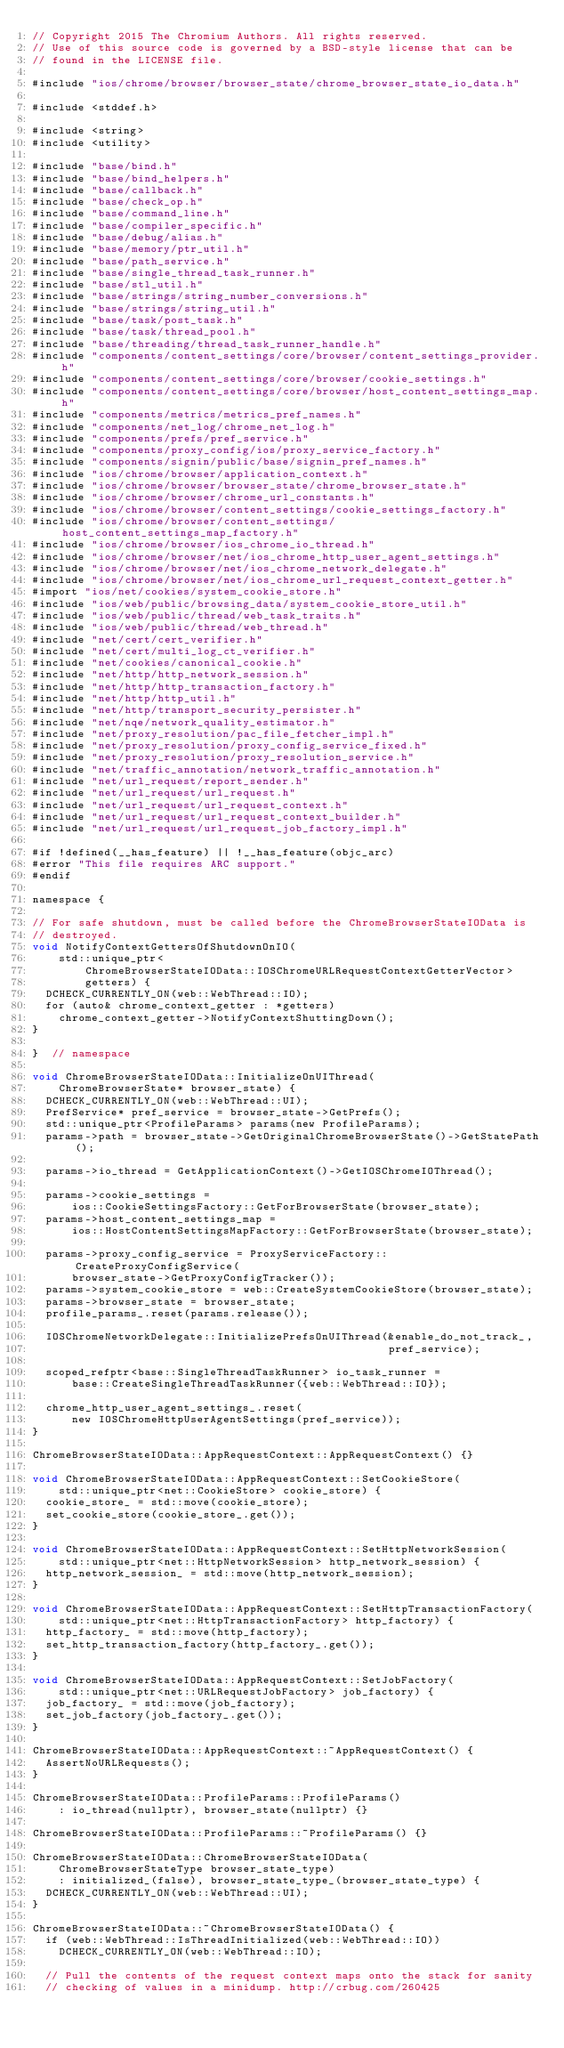<code> <loc_0><loc_0><loc_500><loc_500><_ObjectiveC_>// Copyright 2015 The Chromium Authors. All rights reserved.
// Use of this source code is governed by a BSD-style license that can be
// found in the LICENSE file.

#include "ios/chrome/browser/browser_state/chrome_browser_state_io_data.h"

#include <stddef.h>

#include <string>
#include <utility>

#include "base/bind.h"
#include "base/bind_helpers.h"
#include "base/callback.h"
#include "base/check_op.h"
#include "base/command_line.h"
#include "base/compiler_specific.h"
#include "base/debug/alias.h"
#include "base/memory/ptr_util.h"
#include "base/path_service.h"
#include "base/single_thread_task_runner.h"
#include "base/stl_util.h"
#include "base/strings/string_number_conversions.h"
#include "base/strings/string_util.h"
#include "base/task/post_task.h"
#include "base/task/thread_pool.h"
#include "base/threading/thread_task_runner_handle.h"
#include "components/content_settings/core/browser/content_settings_provider.h"
#include "components/content_settings/core/browser/cookie_settings.h"
#include "components/content_settings/core/browser/host_content_settings_map.h"
#include "components/metrics/metrics_pref_names.h"
#include "components/net_log/chrome_net_log.h"
#include "components/prefs/pref_service.h"
#include "components/proxy_config/ios/proxy_service_factory.h"
#include "components/signin/public/base/signin_pref_names.h"
#include "ios/chrome/browser/application_context.h"
#include "ios/chrome/browser/browser_state/chrome_browser_state.h"
#include "ios/chrome/browser/chrome_url_constants.h"
#include "ios/chrome/browser/content_settings/cookie_settings_factory.h"
#include "ios/chrome/browser/content_settings/host_content_settings_map_factory.h"
#include "ios/chrome/browser/ios_chrome_io_thread.h"
#include "ios/chrome/browser/net/ios_chrome_http_user_agent_settings.h"
#include "ios/chrome/browser/net/ios_chrome_network_delegate.h"
#include "ios/chrome/browser/net/ios_chrome_url_request_context_getter.h"
#import "ios/net/cookies/system_cookie_store.h"
#include "ios/web/public/browsing_data/system_cookie_store_util.h"
#include "ios/web/public/thread/web_task_traits.h"
#include "ios/web/public/thread/web_thread.h"
#include "net/cert/cert_verifier.h"
#include "net/cert/multi_log_ct_verifier.h"
#include "net/cookies/canonical_cookie.h"
#include "net/http/http_network_session.h"
#include "net/http/http_transaction_factory.h"
#include "net/http/http_util.h"
#include "net/http/transport_security_persister.h"
#include "net/nqe/network_quality_estimator.h"
#include "net/proxy_resolution/pac_file_fetcher_impl.h"
#include "net/proxy_resolution/proxy_config_service_fixed.h"
#include "net/proxy_resolution/proxy_resolution_service.h"
#include "net/traffic_annotation/network_traffic_annotation.h"
#include "net/url_request/report_sender.h"
#include "net/url_request/url_request.h"
#include "net/url_request/url_request_context.h"
#include "net/url_request/url_request_context_builder.h"
#include "net/url_request/url_request_job_factory_impl.h"

#if !defined(__has_feature) || !__has_feature(objc_arc)
#error "This file requires ARC support."
#endif

namespace {

// For safe shutdown, must be called before the ChromeBrowserStateIOData is
// destroyed.
void NotifyContextGettersOfShutdownOnIO(
    std::unique_ptr<
        ChromeBrowserStateIOData::IOSChromeURLRequestContextGetterVector>
        getters) {
  DCHECK_CURRENTLY_ON(web::WebThread::IO);
  for (auto& chrome_context_getter : *getters)
    chrome_context_getter->NotifyContextShuttingDown();
}

}  // namespace

void ChromeBrowserStateIOData::InitializeOnUIThread(
    ChromeBrowserState* browser_state) {
  DCHECK_CURRENTLY_ON(web::WebThread::UI);
  PrefService* pref_service = browser_state->GetPrefs();
  std::unique_ptr<ProfileParams> params(new ProfileParams);
  params->path = browser_state->GetOriginalChromeBrowserState()->GetStatePath();

  params->io_thread = GetApplicationContext()->GetIOSChromeIOThread();

  params->cookie_settings =
      ios::CookieSettingsFactory::GetForBrowserState(browser_state);
  params->host_content_settings_map =
      ios::HostContentSettingsMapFactory::GetForBrowserState(browser_state);

  params->proxy_config_service = ProxyServiceFactory::CreateProxyConfigService(
      browser_state->GetProxyConfigTracker());
  params->system_cookie_store = web::CreateSystemCookieStore(browser_state);
  params->browser_state = browser_state;
  profile_params_.reset(params.release());

  IOSChromeNetworkDelegate::InitializePrefsOnUIThread(&enable_do_not_track_,
                                                      pref_service);

  scoped_refptr<base::SingleThreadTaskRunner> io_task_runner =
      base::CreateSingleThreadTaskRunner({web::WebThread::IO});

  chrome_http_user_agent_settings_.reset(
      new IOSChromeHttpUserAgentSettings(pref_service));
}

ChromeBrowserStateIOData::AppRequestContext::AppRequestContext() {}

void ChromeBrowserStateIOData::AppRequestContext::SetCookieStore(
    std::unique_ptr<net::CookieStore> cookie_store) {
  cookie_store_ = std::move(cookie_store);
  set_cookie_store(cookie_store_.get());
}

void ChromeBrowserStateIOData::AppRequestContext::SetHttpNetworkSession(
    std::unique_ptr<net::HttpNetworkSession> http_network_session) {
  http_network_session_ = std::move(http_network_session);
}

void ChromeBrowserStateIOData::AppRequestContext::SetHttpTransactionFactory(
    std::unique_ptr<net::HttpTransactionFactory> http_factory) {
  http_factory_ = std::move(http_factory);
  set_http_transaction_factory(http_factory_.get());
}

void ChromeBrowserStateIOData::AppRequestContext::SetJobFactory(
    std::unique_ptr<net::URLRequestJobFactory> job_factory) {
  job_factory_ = std::move(job_factory);
  set_job_factory(job_factory_.get());
}

ChromeBrowserStateIOData::AppRequestContext::~AppRequestContext() {
  AssertNoURLRequests();
}

ChromeBrowserStateIOData::ProfileParams::ProfileParams()
    : io_thread(nullptr), browser_state(nullptr) {}

ChromeBrowserStateIOData::ProfileParams::~ProfileParams() {}

ChromeBrowserStateIOData::ChromeBrowserStateIOData(
    ChromeBrowserStateType browser_state_type)
    : initialized_(false), browser_state_type_(browser_state_type) {
  DCHECK_CURRENTLY_ON(web::WebThread::UI);
}

ChromeBrowserStateIOData::~ChromeBrowserStateIOData() {
  if (web::WebThread::IsThreadInitialized(web::WebThread::IO))
    DCHECK_CURRENTLY_ON(web::WebThread::IO);

  // Pull the contents of the request context maps onto the stack for sanity
  // checking of values in a minidump. http://crbug.com/260425</code> 